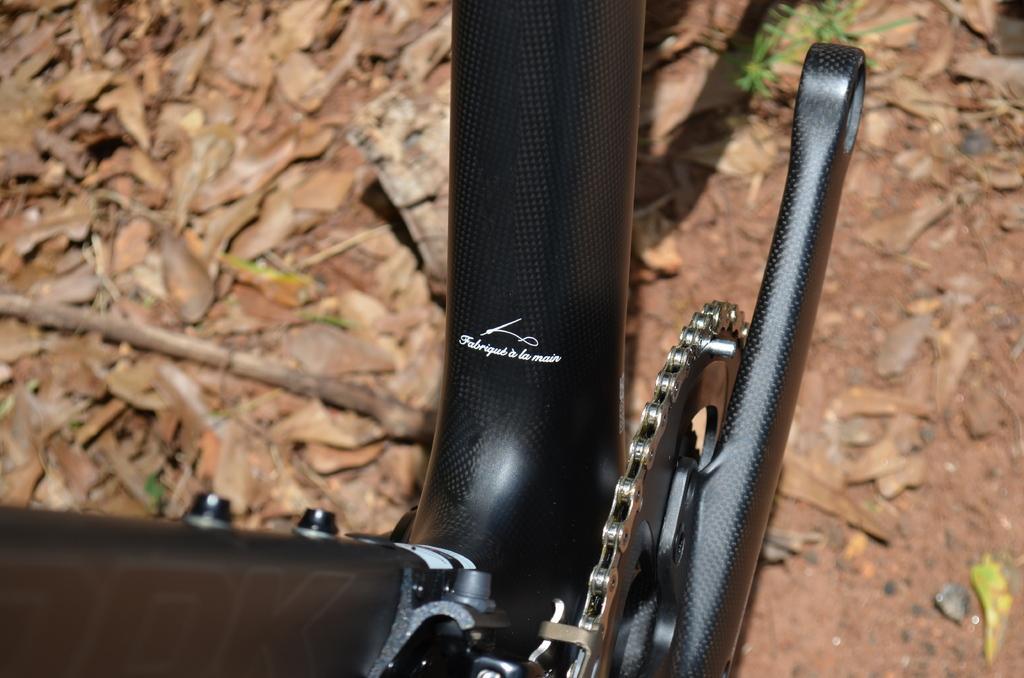Can you describe this image briefly? This picture is mainly highlighted with the partial part of a bicycle. At the bottom portion of the picture we can see the dried leaves , twig on the ground. 